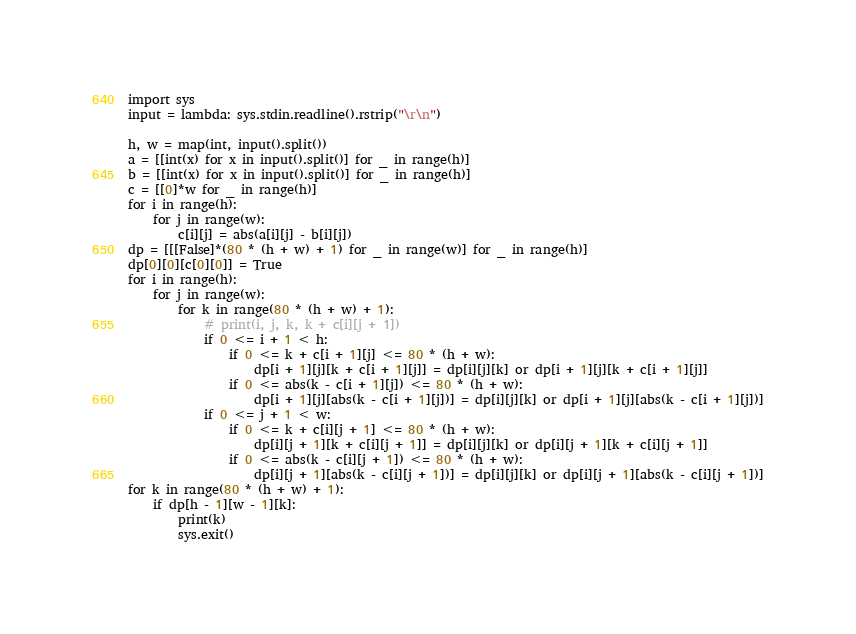Convert code to text. <code><loc_0><loc_0><loc_500><loc_500><_Python_>import sys
input = lambda: sys.stdin.readline().rstrip("\r\n")

h, w = map(int, input().split())
a = [[int(x) for x in input().split()] for _ in range(h)]
b = [[int(x) for x in input().split()] for _ in range(h)]
c = [[0]*w for _ in range(h)]
for i in range(h):
    for j in range(w):
        c[i][j] = abs(a[i][j] - b[i][j])
dp = [[[False]*(80 * (h + w) + 1) for _ in range(w)] for _ in range(h)]
dp[0][0][c[0][0]] = True
for i in range(h):
    for j in range(w):
        for k in range(80 * (h + w) + 1):
            # print(i, j, k, k + c[i][j + 1])
            if 0 <= i + 1 < h:
                if 0 <= k + c[i + 1][j] <= 80 * (h + w):
                    dp[i + 1][j][k + c[i + 1][j]] = dp[i][j][k] or dp[i + 1][j][k + c[i + 1][j]]
                if 0 <= abs(k - c[i + 1][j]) <= 80 * (h + w):
                    dp[i + 1][j][abs(k - c[i + 1][j])] = dp[i][j][k] or dp[i + 1][j][abs(k - c[i + 1][j])]
            if 0 <= j + 1 < w:
                if 0 <= k + c[i][j + 1] <= 80 * (h + w):
                    dp[i][j + 1][k + c[i][j + 1]] = dp[i][j][k] or dp[i][j + 1][k + c[i][j + 1]]
                if 0 <= abs(k - c[i][j + 1]) <= 80 * (h + w):
                    dp[i][j + 1][abs(k - c[i][j + 1])] = dp[i][j][k] or dp[i][j + 1][abs(k - c[i][j + 1])]
for k in range(80 * (h + w) + 1):
    if dp[h - 1][w - 1][k]:
        print(k)
        sys.exit()</code> 